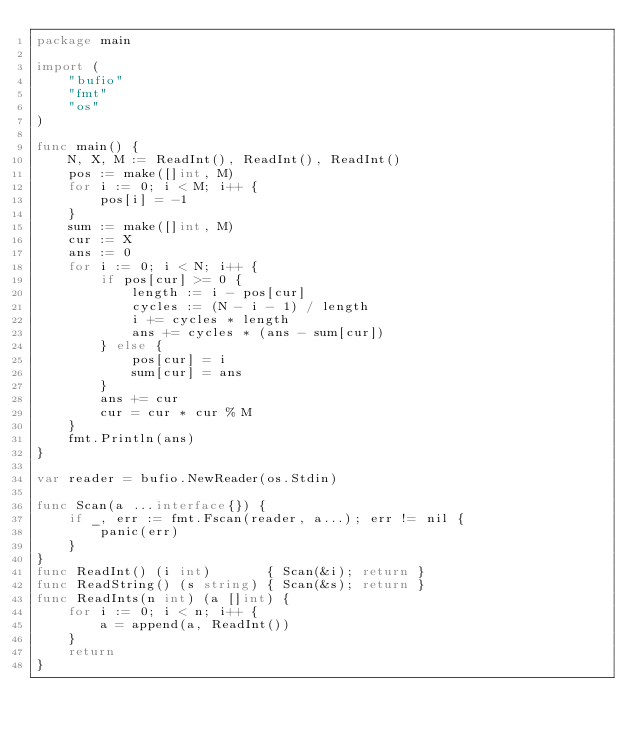<code> <loc_0><loc_0><loc_500><loc_500><_Go_>package main

import (
	"bufio"
	"fmt"
	"os"
)

func main() {
	N, X, M := ReadInt(), ReadInt(), ReadInt()
	pos := make([]int, M)
	for i := 0; i < M; i++ {
		pos[i] = -1
	}
	sum := make([]int, M)
	cur := X
	ans := 0
	for i := 0; i < N; i++ {
		if pos[cur] >= 0 {
			length := i - pos[cur]
			cycles := (N - i - 1) / length
			i += cycles * length
			ans += cycles * (ans - sum[cur])
		} else {
			pos[cur] = i
			sum[cur] = ans
		}
		ans += cur
		cur = cur * cur % M
	}
	fmt.Println(ans)
}

var reader = bufio.NewReader(os.Stdin)

func Scan(a ...interface{}) {
	if _, err := fmt.Fscan(reader, a...); err != nil {
		panic(err)
	}
}
func ReadInt() (i int)       { Scan(&i); return }
func ReadString() (s string) { Scan(&s); return }
func ReadInts(n int) (a []int) {
	for i := 0; i < n; i++ {
		a = append(a, ReadInt())
	}
	return
}
</code> 